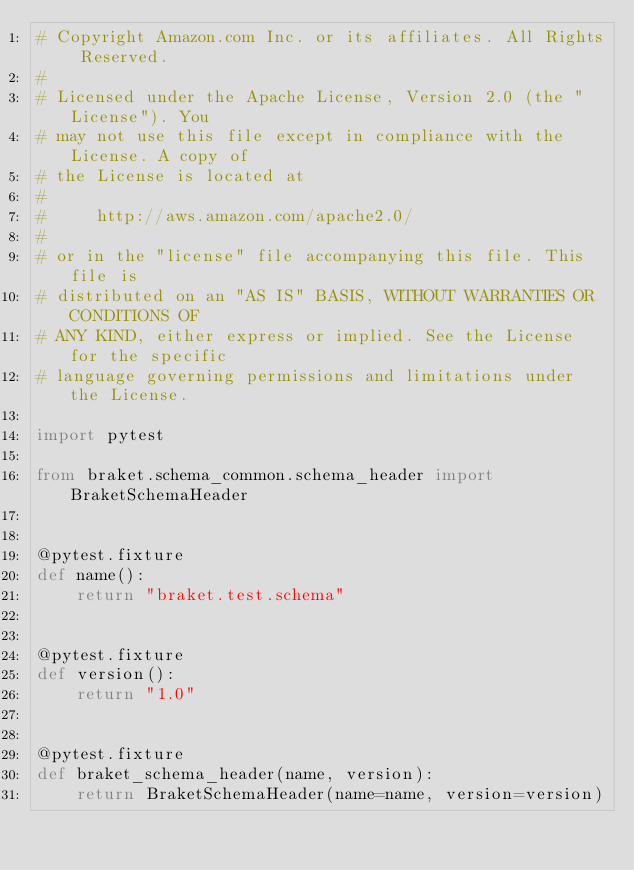Convert code to text. <code><loc_0><loc_0><loc_500><loc_500><_Python_># Copyright Amazon.com Inc. or its affiliates. All Rights Reserved.
#
# Licensed under the Apache License, Version 2.0 (the "License"). You
# may not use this file except in compliance with the License. A copy of
# the License is located at
#
#     http://aws.amazon.com/apache2.0/
#
# or in the "license" file accompanying this file. This file is
# distributed on an "AS IS" BASIS, WITHOUT WARRANTIES OR CONDITIONS OF
# ANY KIND, either express or implied. See the License for the specific
# language governing permissions and limitations under the License.

import pytest

from braket.schema_common.schema_header import BraketSchemaHeader


@pytest.fixture
def name():
    return "braket.test.schema"


@pytest.fixture
def version():
    return "1.0"


@pytest.fixture
def braket_schema_header(name, version):
    return BraketSchemaHeader(name=name, version=version)
</code> 